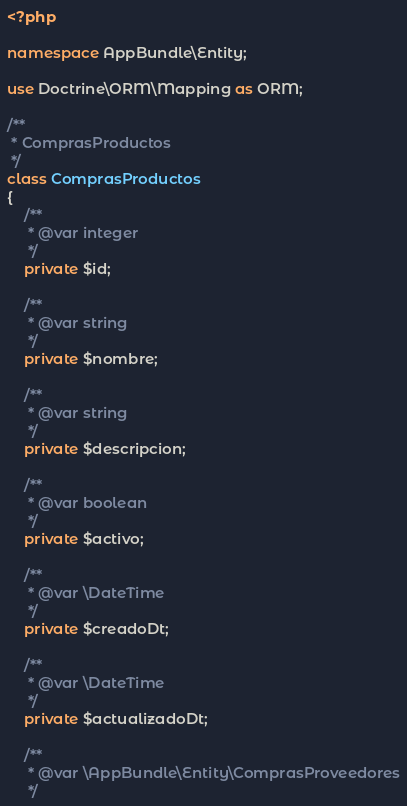Convert code to text. <code><loc_0><loc_0><loc_500><loc_500><_PHP_><?php

namespace AppBundle\Entity;

use Doctrine\ORM\Mapping as ORM;

/**
 * ComprasProductos
 */
class ComprasProductos
{
    /**
     * @var integer
     */
    private $id;

    /**
     * @var string
     */
    private $nombre;

    /**
     * @var string
     */
    private $descripcion;

    /**
     * @var boolean
     */
    private $activo;

    /**
     * @var \DateTime
     */
    private $creadoDt;

    /**
     * @var \DateTime
     */
    private $actualizadoDt;

    /**
     * @var \AppBundle\Entity\ComprasProveedores
     */</code> 